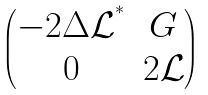<formula> <loc_0><loc_0><loc_500><loc_500>\begin{pmatrix} - 2 \Delta \mathcal { L } ^ { ^ { * } } & G \\ 0 & 2 \mathcal { L } \end{pmatrix}</formula> 